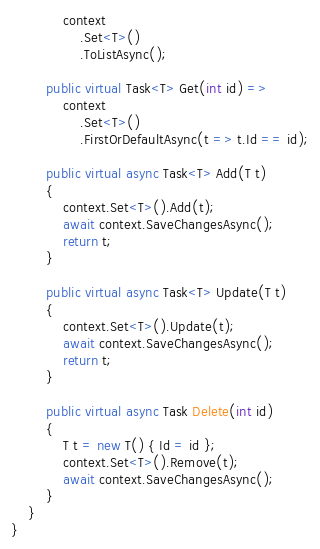Convert code to text. <code><loc_0><loc_0><loc_500><loc_500><_C#_>            context
                .Set<T>()
                .ToListAsync();

        public virtual Task<T> Get(int id) =>
            context
                .Set<T>()
                .FirstOrDefaultAsync(t => t.Id == id);

        public virtual async Task<T> Add(T t)
        {
            context.Set<T>().Add(t);
            await context.SaveChangesAsync();
            return t;
        }

        public virtual async Task<T> Update(T t)
        {
            context.Set<T>().Update(t);
            await context.SaveChangesAsync();
            return t;
        }

        public virtual async Task Delete(int id)
        {
            T t = new T() { Id = id };
            context.Set<T>().Remove(t);
            await context.SaveChangesAsync();
        }
    }
}</code> 